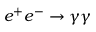Convert formula to latex. <formula><loc_0><loc_0><loc_500><loc_500>e ^ { + } e ^ { - } \to \gamma \gamma</formula> 